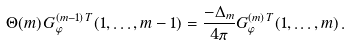<formula> <loc_0><loc_0><loc_500><loc_500>\Theta ( m ) \, G ^ { ( m - 1 ) \, T } _ { \varphi } ( 1 , \dots , m - 1 ) = \frac { - \Delta _ { m } } { 4 \pi } G ^ { ( m ) \, T } _ { \varphi } ( 1 , \dots , m ) \, .</formula> 